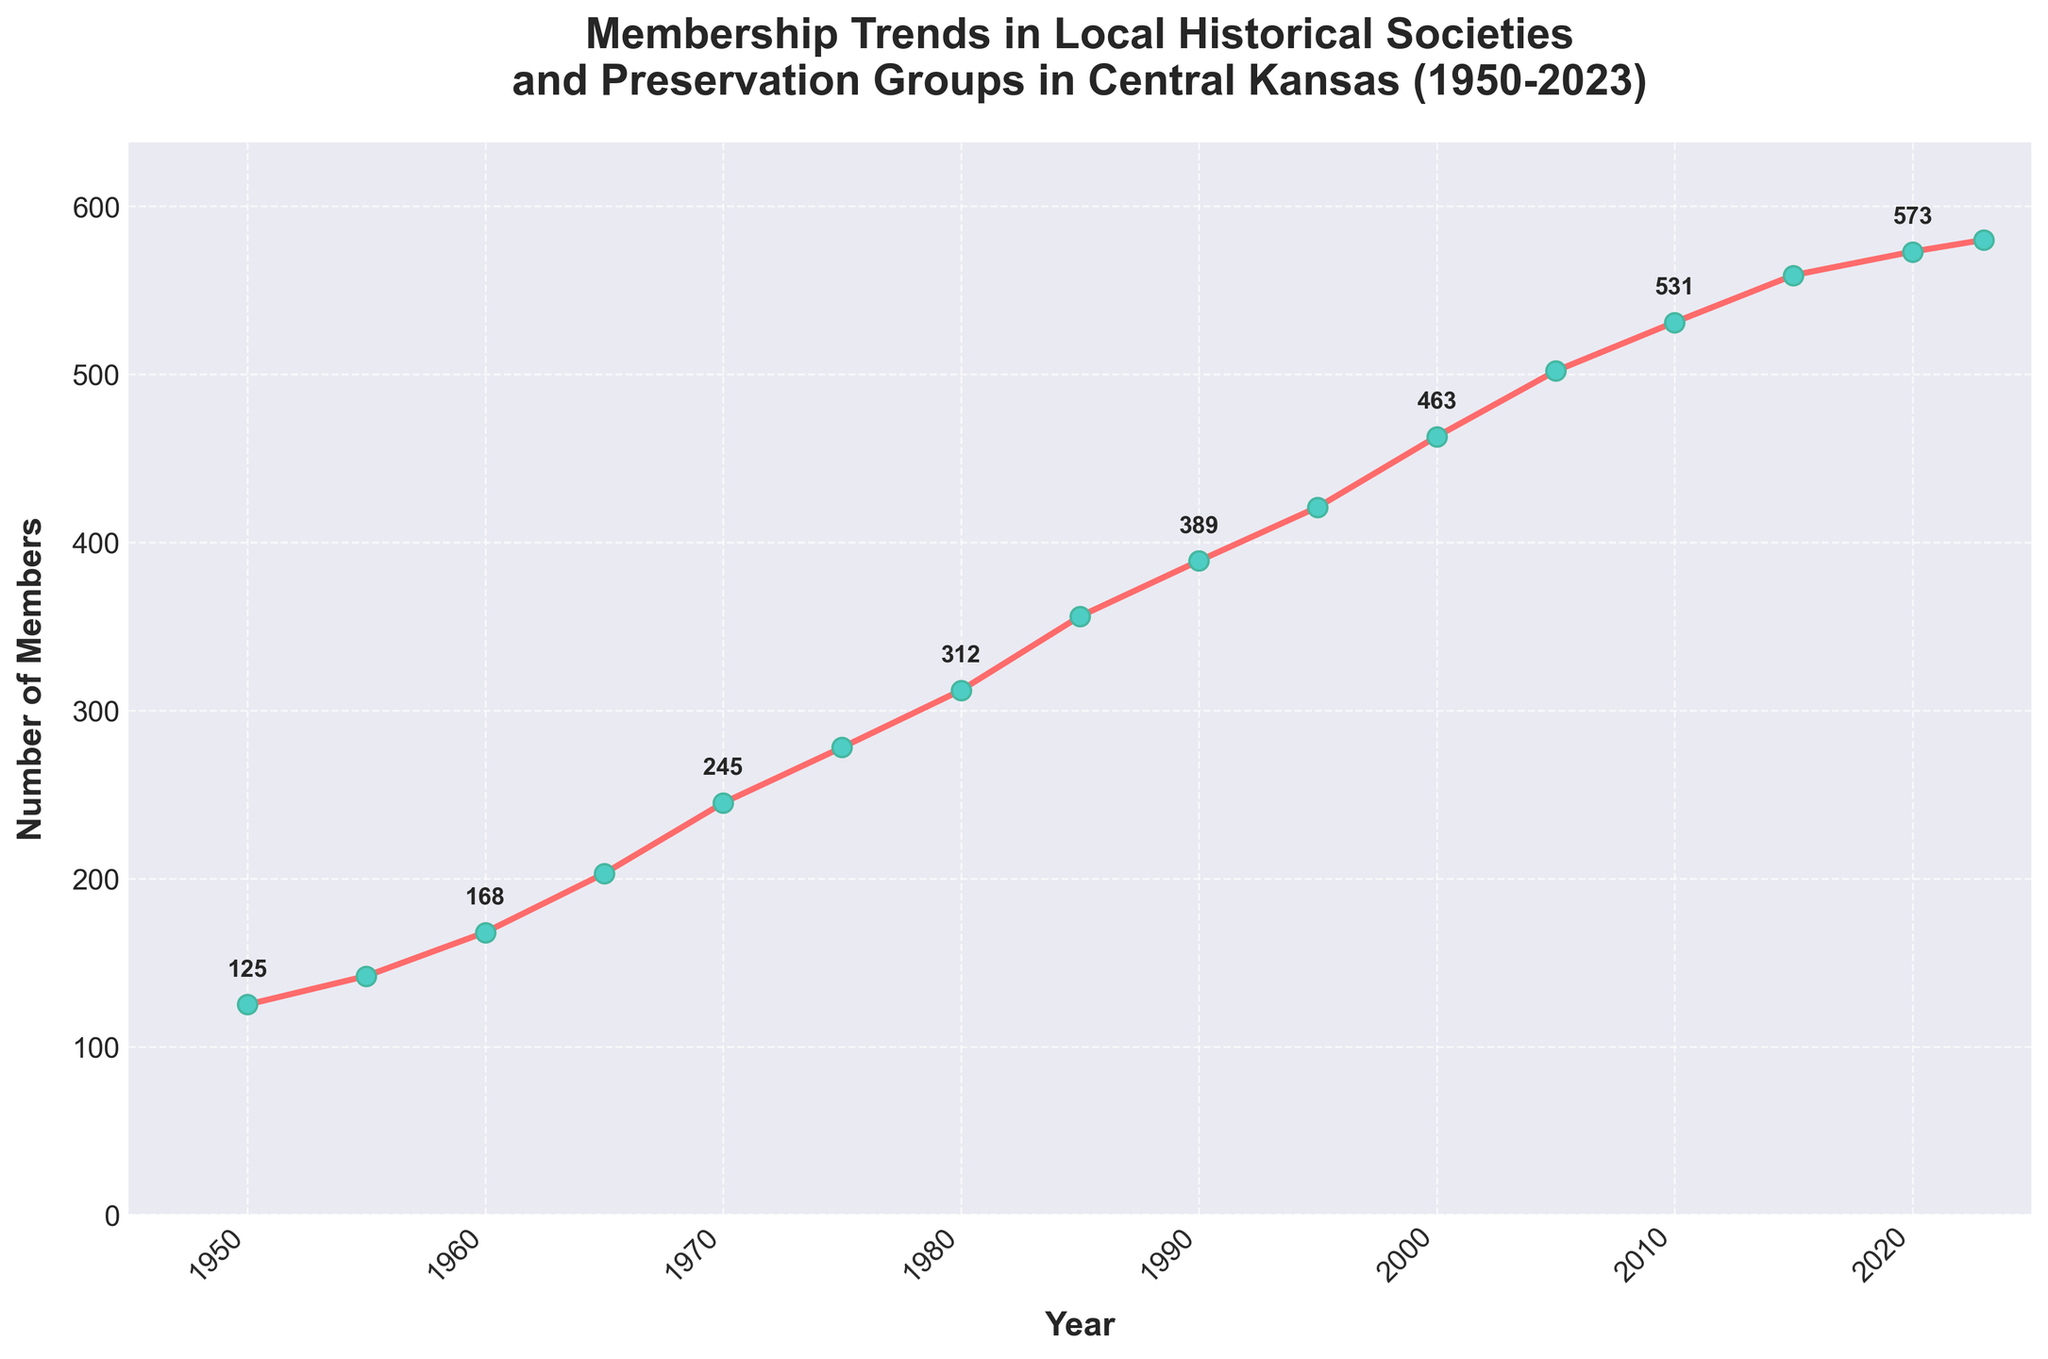What was the number of members in the year 1980? Locate the data point for the year 1980, which shows the membership number at that year.
Answer: 312 How many more members were there in 2023 compared to 1950? Find the number of members in 2023 (580) and 1950 (125), then subtract the latter from the former to get the difference: 580 - 125.
Answer: 455 Between which two consecutive years did the membership increase the most? Look at the differences in membership numbers between every consecutive pair of data points. Identify the pair with the largest difference.
Answer: 2000 and 2005 What's the average number of members for the years 1950, 2000, and 2023? Sum the membership numbers for the years 1950 (125), 2000 (463), and 2023 (580) and then divide by 3: (125 + 463 + 580) / 3.
Answer: 389.33 Which year saw the highest number of members recorded in the data? Identify the peak value from the plot, which occurs at 2023 with 580 members.
Answer: 2023 Is the number of members in 1995 greater than the number of members in 1985? Compare the membership number in 1995 (421) with that in 1985 (356).
Answer: Yes Did the membership numbers ever decrease from one recorded year to the next? Review the trend line; if it always goes upward, then the number of members never decreased.
Answer: No What is the total number of members added between 1950 and 2023? The total number of members added can be found by subtracting the membership number in 1950 (125) from that in 2023 (580).
Answer: 455 By how much did the membership increase from 1955 to 1960? Subtract the membership number in 1955 (142) from that in 1960 (168) to find the increase: 168 - 142.
Answer: 26 What is the approximate overall trend shown in the plot? Observe the general direction of the line across the time span; it shows a consistent upward trend.
Answer: Upward trend 